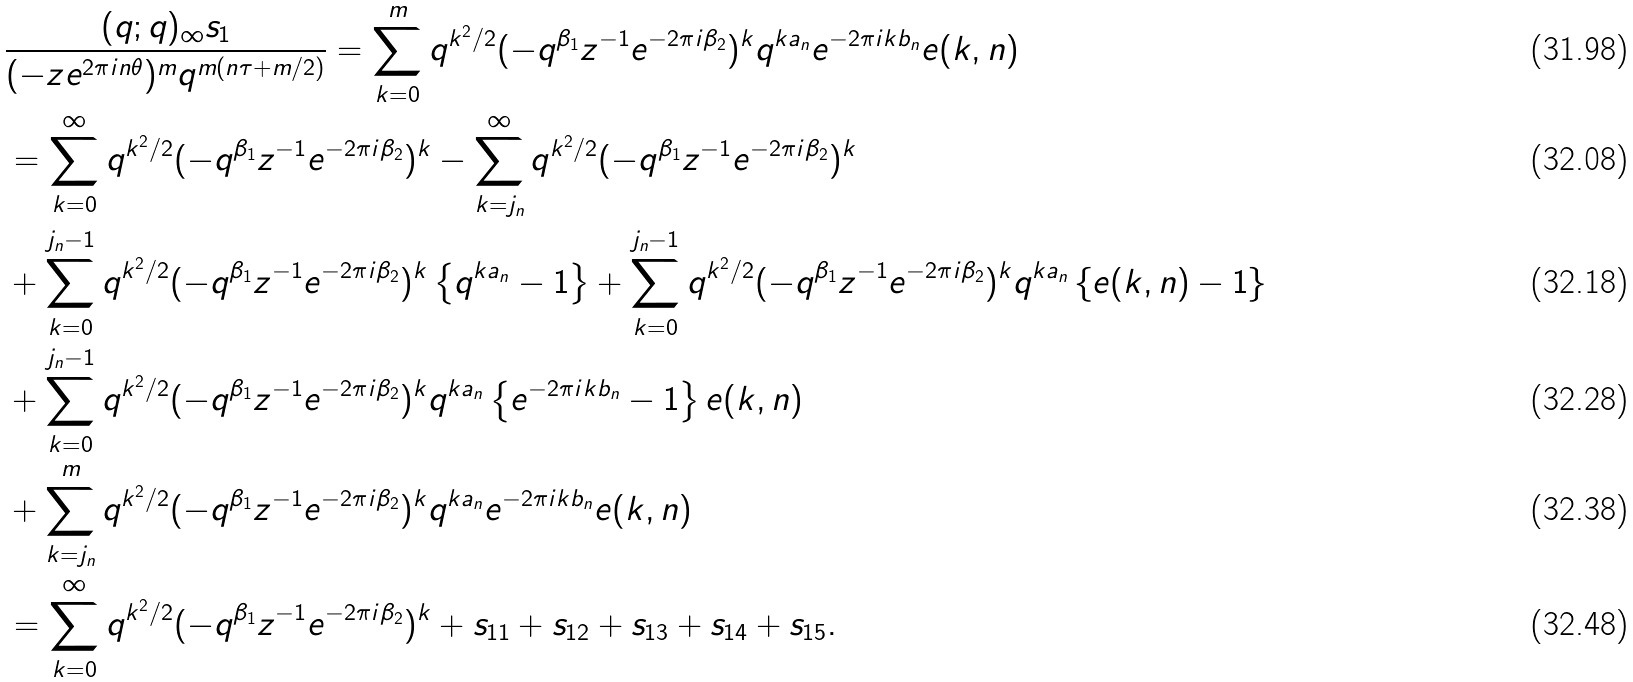<formula> <loc_0><loc_0><loc_500><loc_500>& \frac { ( q ; q ) _ { \infty } s _ { 1 } } { ( - z e ^ { 2 \pi i n \theta } ) ^ { m } q ^ { m ( n \tau + m / 2 ) } } = \sum _ { k = 0 } ^ { m } q ^ { k ^ { 2 } / 2 } ( - q ^ { \beta _ { 1 } } z ^ { - 1 } e ^ { - 2 \pi i \beta _ { 2 } } ) ^ { k } q ^ { k a _ { n } } e ^ { - 2 \pi i k b _ { n } } e ( k , n ) \\ & = \sum _ { k = 0 } ^ { \infty } q ^ { k ^ { 2 } / 2 } ( - q ^ { \beta _ { 1 } } z ^ { - 1 } e ^ { - 2 \pi i \beta _ { 2 } } ) ^ { k } - \sum _ { k = j _ { n } } ^ { \infty } q ^ { k ^ { 2 } / 2 } ( - q ^ { \beta _ { 1 } } z ^ { - 1 } e ^ { - 2 \pi i \beta _ { 2 } } ) ^ { k } \\ & + \sum _ { k = 0 } ^ { j _ { n } - 1 } q ^ { k ^ { 2 } / 2 } ( - q ^ { \beta _ { 1 } } z ^ { - 1 } e ^ { - 2 \pi i \beta _ { 2 } } ) ^ { k } \left \{ q ^ { k a _ { n } } - 1 \right \} + \sum _ { k = 0 } ^ { j _ { n } - 1 } q ^ { k ^ { 2 } / 2 } ( - q ^ { \beta _ { 1 } } z ^ { - 1 } e ^ { - 2 \pi i \beta _ { 2 } } ) ^ { k } q ^ { k a _ { n } } \left \{ e ( k , n ) - 1 \right \} \\ & + \sum _ { k = 0 } ^ { j _ { n } - 1 } q ^ { k ^ { 2 } / 2 } ( - q ^ { \beta _ { 1 } } z ^ { - 1 } e ^ { - 2 \pi i \beta _ { 2 } } ) ^ { k } q ^ { k a _ { n } } \left \{ e ^ { - 2 \pi i k b _ { n } } - 1 \right \} e ( k , n ) \\ & + \sum _ { k = j _ { n } } ^ { m } q ^ { k ^ { 2 } / 2 } ( - q ^ { \beta _ { 1 } } z ^ { - 1 } e ^ { - 2 \pi i \beta _ { 2 } } ) ^ { k } q ^ { k a _ { n } } e ^ { - 2 \pi i k b _ { n } } e ( k , n ) \\ & = \sum _ { k = 0 } ^ { \infty } q ^ { k ^ { 2 } / 2 } ( - q ^ { \beta _ { 1 } } z ^ { - 1 } e ^ { - 2 \pi i \beta _ { 2 } } ) ^ { k } + s _ { 1 1 } + s _ { 1 2 } + s _ { 1 3 } + s _ { 1 4 } + s _ { 1 5 } .</formula> 